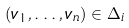Convert formula to latex. <formula><loc_0><loc_0><loc_500><loc_500>( v _ { 1 } , \dots , v _ { n } ) \in \Delta _ { i }</formula> 